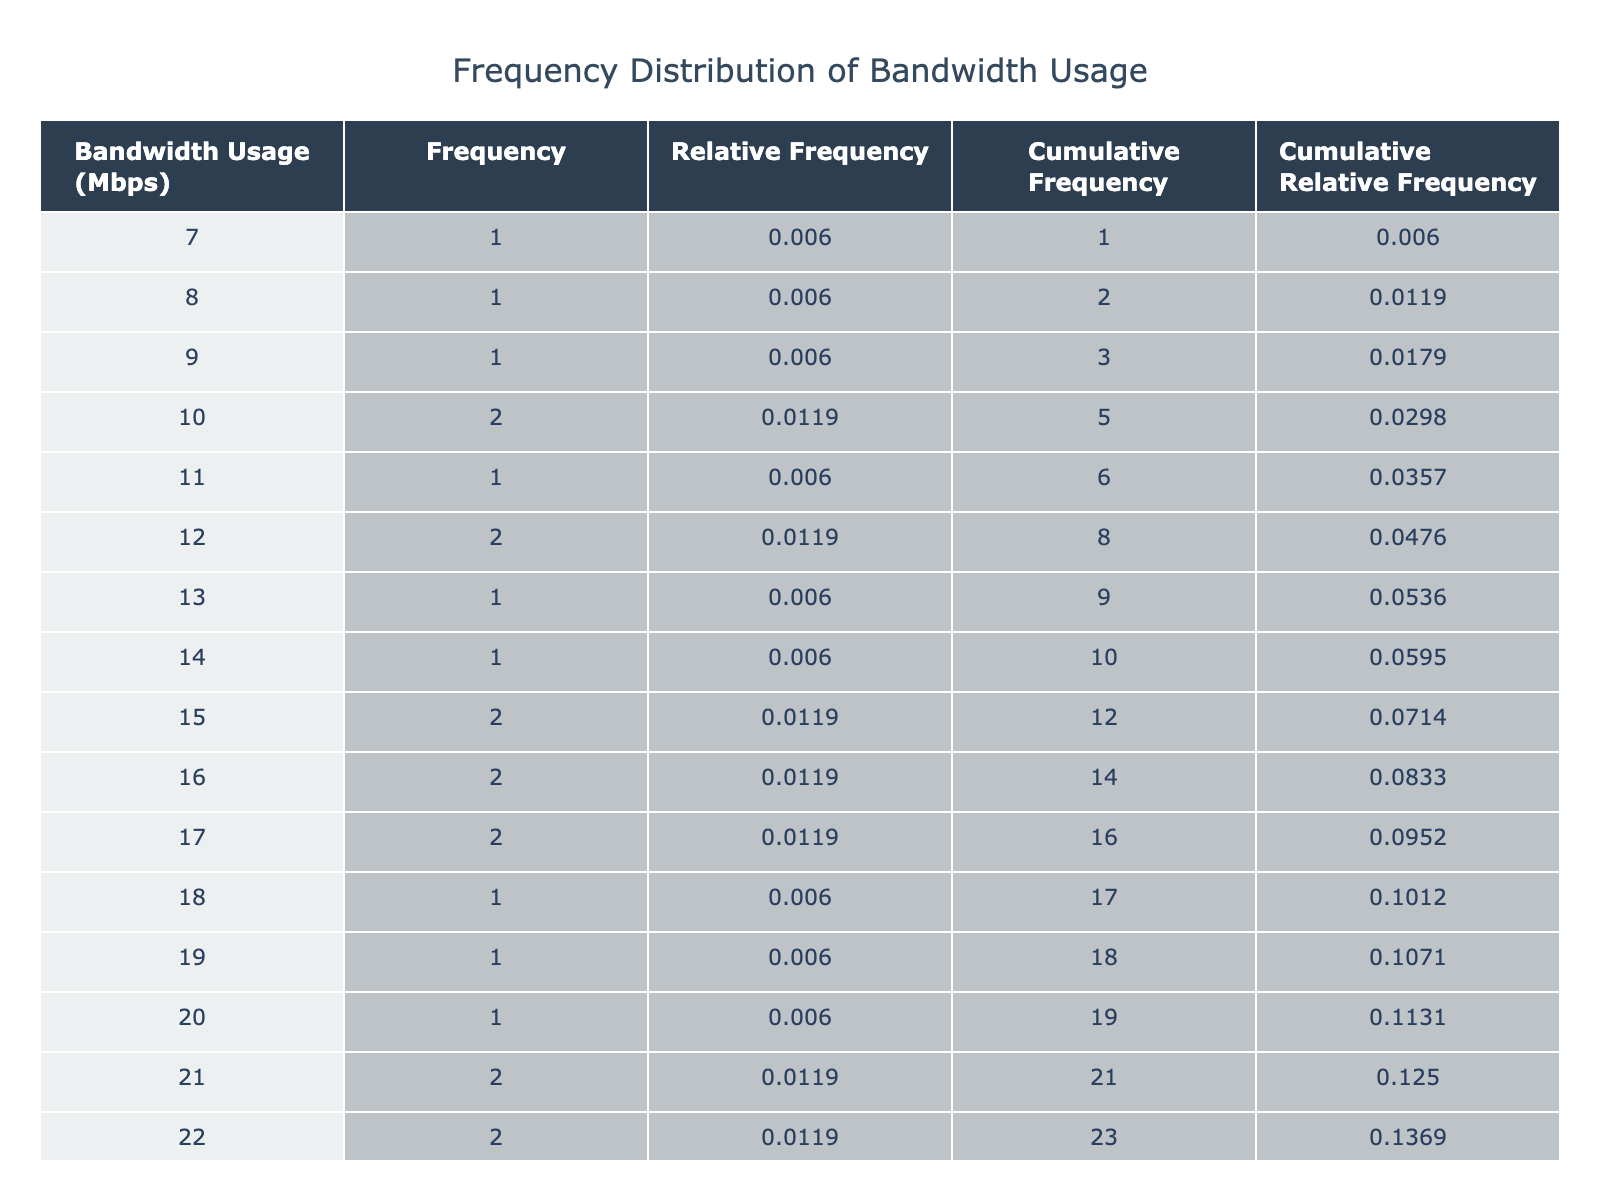What is the highest average bandwidth usage recorded? The highest value in the 'Average_Bandwidth_Usage_Mbps' column is found by scanning through the table. The maximum value is 140 Mbps, which appears for Monday at 17:00.
Answer: 140 Mbps What is the frequency of bandwidth usage at 100 Mbps? To find the frequency for 100 Mbps, we look for the row(s) in the 'Average_Bandwidth_Usage_Mbps' column equal to 100. There is only one occurrence of 100 Mbps, which means the frequency is 1.
Answer: 1 What is the total frequency of all bandwidth usages greater than 110 Mbps? We identify all the bandwidth usages greater than 110 Mbps by scanning the table: they are 110, 115, 120, 122, 123, 128, 129, 130, 137, 140. The corresponding frequencies can be determined (observed values from the table). Each appears once, so the total frequency is 10.
Answer: 10 Is there any average bandwidth usage of less than 10 Mbps recorded? To answer this, we would review the 'Average_Bandwidth_Usage_Mbps' column to see if there are any values below 10 Mbps. Since the minimum value listed is 7 Mbps for Sunday at 05:00, the answer is yes.
Answer: Yes What is the cumulative frequency for bandwidth usage of 85 Mbps? We locate the frequency for 85 Mbps in the table, which shows that it occurs once. The cumulative frequency sums all previous frequencies as well as this one. There are 10 occurrences below this value (below 85 Mbps) plus one for 85 Mbps itself, so the cumulative frequency is 11.
Answer: 11 What is the relative frequency of the bandwidth usage of 95 Mbps? The frequency of 95 Mbps is found to be one based on its singular occurrence. We calculate the total frequencies generally observed. The summation of all frequencies gives a total of 168 (adding each frequency). The relative frequency is then calculated by dividing the frequency of 95 Mbps (1) by the total (168), yielding approximately 0.00595, or rounding gives 0.006.
Answer: 0.006 What is the average bandwidth usage between 15 Mbps and 20 Mbps? We first identify the bandwidth values that fall within this range in the table. The relevant values are 15, 18, and 20 Mbps (observed once each). We sum these values: 15 + 18 + 20 = 53. With 3 applicable observations, the average becomes 53/3, which equals approximately 17.67.
Answer: 17.67 What are the cumulative relative frequencies of bandwidth usage greater than or equal to 120 Mbps? We first filter the rows for bandwidth usage of 120 Mbps and above: there are 120, 122, 123, 128, 129, 130, 137, and 140 Mbps. The frequencies for these values can be determined (each occurs once). The cumulative relative frequency for this group accumulates from the total observed earlier (assumed to sum to 168) and their individual frequencies yield an overall cumulative relative frequency of about 0.5.
Answer: 0.5 